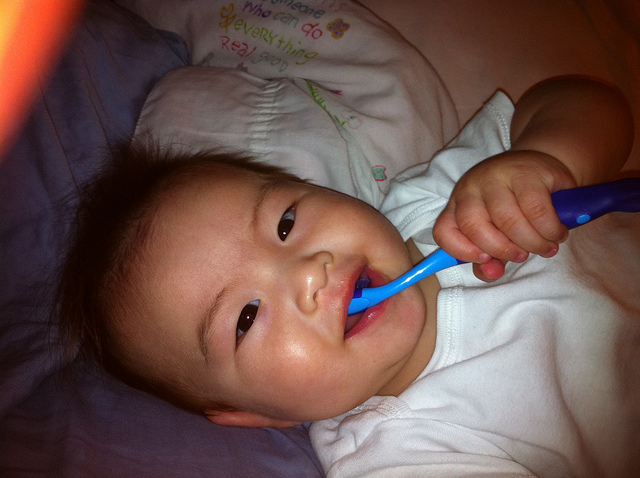Extract all visible text content from this image. every Real good da can thing who 